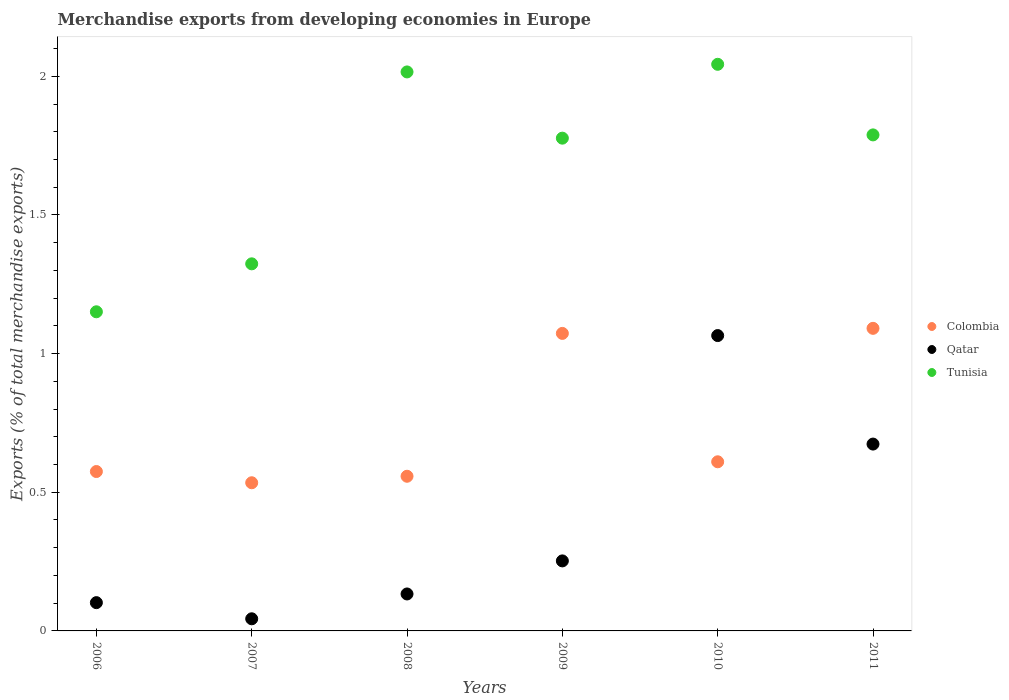What is the percentage of total merchandise exports in Colombia in 2010?
Your answer should be very brief. 0.61. Across all years, what is the maximum percentage of total merchandise exports in Colombia?
Your answer should be compact. 1.09. Across all years, what is the minimum percentage of total merchandise exports in Colombia?
Provide a succinct answer. 0.53. In which year was the percentage of total merchandise exports in Colombia maximum?
Provide a succinct answer. 2011. What is the total percentage of total merchandise exports in Qatar in the graph?
Provide a succinct answer. 2.27. What is the difference between the percentage of total merchandise exports in Qatar in 2007 and that in 2009?
Offer a very short reply. -0.21. What is the difference between the percentage of total merchandise exports in Tunisia in 2006 and the percentage of total merchandise exports in Colombia in 2007?
Provide a short and direct response. 0.62. What is the average percentage of total merchandise exports in Qatar per year?
Your answer should be very brief. 0.38. In the year 2011, what is the difference between the percentage of total merchandise exports in Qatar and percentage of total merchandise exports in Colombia?
Your answer should be very brief. -0.42. In how many years, is the percentage of total merchandise exports in Qatar greater than 1 %?
Your response must be concise. 1. What is the ratio of the percentage of total merchandise exports in Tunisia in 2008 to that in 2009?
Make the answer very short. 1.13. Is the percentage of total merchandise exports in Tunisia in 2006 less than that in 2008?
Ensure brevity in your answer.  Yes. What is the difference between the highest and the second highest percentage of total merchandise exports in Qatar?
Make the answer very short. 0.39. What is the difference between the highest and the lowest percentage of total merchandise exports in Qatar?
Provide a short and direct response. 1.02. In how many years, is the percentage of total merchandise exports in Tunisia greater than the average percentage of total merchandise exports in Tunisia taken over all years?
Keep it short and to the point. 4. Is it the case that in every year, the sum of the percentage of total merchandise exports in Qatar and percentage of total merchandise exports in Colombia  is greater than the percentage of total merchandise exports in Tunisia?
Offer a very short reply. No. Does the percentage of total merchandise exports in Qatar monotonically increase over the years?
Provide a succinct answer. No. Is the percentage of total merchandise exports in Tunisia strictly greater than the percentage of total merchandise exports in Qatar over the years?
Offer a terse response. Yes. How many dotlines are there?
Your answer should be compact. 3. What is the difference between two consecutive major ticks on the Y-axis?
Offer a terse response. 0.5. Does the graph contain any zero values?
Offer a very short reply. No. Does the graph contain grids?
Offer a terse response. No. Where does the legend appear in the graph?
Provide a short and direct response. Center right. How many legend labels are there?
Make the answer very short. 3. How are the legend labels stacked?
Your answer should be compact. Vertical. What is the title of the graph?
Offer a very short reply. Merchandise exports from developing economies in Europe. What is the label or title of the Y-axis?
Provide a succinct answer. Exports (% of total merchandise exports). What is the Exports (% of total merchandise exports) of Colombia in 2006?
Make the answer very short. 0.57. What is the Exports (% of total merchandise exports) of Qatar in 2006?
Offer a very short reply. 0.1. What is the Exports (% of total merchandise exports) of Tunisia in 2006?
Your answer should be compact. 1.15. What is the Exports (% of total merchandise exports) in Colombia in 2007?
Ensure brevity in your answer.  0.53. What is the Exports (% of total merchandise exports) of Qatar in 2007?
Offer a very short reply. 0.04. What is the Exports (% of total merchandise exports) in Tunisia in 2007?
Ensure brevity in your answer.  1.32. What is the Exports (% of total merchandise exports) of Colombia in 2008?
Your response must be concise. 0.56. What is the Exports (% of total merchandise exports) in Qatar in 2008?
Keep it short and to the point. 0.13. What is the Exports (% of total merchandise exports) of Tunisia in 2008?
Provide a short and direct response. 2.02. What is the Exports (% of total merchandise exports) of Colombia in 2009?
Keep it short and to the point. 1.07. What is the Exports (% of total merchandise exports) of Qatar in 2009?
Provide a succinct answer. 0.25. What is the Exports (% of total merchandise exports) in Tunisia in 2009?
Your response must be concise. 1.78. What is the Exports (% of total merchandise exports) in Colombia in 2010?
Make the answer very short. 0.61. What is the Exports (% of total merchandise exports) in Qatar in 2010?
Ensure brevity in your answer.  1.07. What is the Exports (% of total merchandise exports) of Tunisia in 2010?
Ensure brevity in your answer.  2.04. What is the Exports (% of total merchandise exports) of Colombia in 2011?
Provide a succinct answer. 1.09. What is the Exports (% of total merchandise exports) of Qatar in 2011?
Provide a short and direct response. 0.67. What is the Exports (% of total merchandise exports) of Tunisia in 2011?
Give a very brief answer. 1.79. Across all years, what is the maximum Exports (% of total merchandise exports) in Colombia?
Your answer should be very brief. 1.09. Across all years, what is the maximum Exports (% of total merchandise exports) of Qatar?
Give a very brief answer. 1.07. Across all years, what is the maximum Exports (% of total merchandise exports) of Tunisia?
Your answer should be compact. 2.04. Across all years, what is the minimum Exports (% of total merchandise exports) in Colombia?
Your answer should be compact. 0.53. Across all years, what is the minimum Exports (% of total merchandise exports) in Qatar?
Your response must be concise. 0.04. Across all years, what is the minimum Exports (% of total merchandise exports) in Tunisia?
Your response must be concise. 1.15. What is the total Exports (% of total merchandise exports) in Colombia in the graph?
Your response must be concise. 4.44. What is the total Exports (% of total merchandise exports) in Qatar in the graph?
Offer a very short reply. 2.27. What is the total Exports (% of total merchandise exports) in Tunisia in the graph?
Make the answer very short. 10.1. What is the difference between the Exports (% of total merchandise exports) in Colombia in 2006 and that in 2007?
Keep it short and to the point. 0.04. What is the difference between the Exports (% of total merchandise exports) of Qatar in 2006 and that in 2007?
Offer a very short reply. 0.06. What is the difference between the Exports (% of total merchandise exports) in Tunisia in 2006 and that in 2007?
Your answer should be very brief. -0.17. What is the difference between the Exports (% of total merchandise exports) in Colombia in 2006 and that in 2008?
Give a very brief answer. 0.02. What is the difference between the Exports (% of total merchandise exports) in Qatar in 2006 and that in 2008?
Provide a succinct answer. -0.03. What is the difference between the Exports (% of total merchandise exports) in Tunisia in 2006 and that in 2008?
Provide a succinct answer. -0.86. What is the difference between the Exports (% of total merchandise exports) in Colombia in 2006 and that in 2009?
Provide a succinct answer. -0.5. What is the difference between the Exports (% of total merchandise exports) of Qatar in 2006 and that in 2009?
Provide a short and direct response. -0.15. What is the difference between the Exports (% of total merchandise exports) of Tunisia in 2006 and that in 2009?
Your answer should be compact. -0.63. What is the difference between the Exports (% of total merchandise exports) in Colombia in 2006 and that in 2010?
Provide a succinct answer. -0.04. What is the difference between the Exports (% of total merchandise exports) in Qatar in 2006 and that in 2010?
Give a very brief answer. -0.96. What is the difference between the Exports (% of total merchandise exports) in Tunisia in 2006 and that in 2010?
Your response must be concise. -0.89. What is the difference between the Exports (% of total merchandise exports) in Colombia in 2006 and that in 2011?
Your answer should be compact. -0.52. What is the difference between the Exports (% of total merchandise exports) of Qatar in 2006 and that in 2011?
Keep it short and to the point. -0.57. What is the difference between the Exports (% of total merchandise exports) in Tunisia in 2006 and that in 2011?
Offer a terse response. -0.64. What is the difference between the Exports (% of total merchandise exports) in Colombia in 2007 and that in 2008?
Offer a terse response. -0.02. What is the difference between the Exports (% of total merchandise exports) of Qatar in 2007 and that in 2008?
Give a very brief answer. -0.09. What is the difference between the Exports (% of total merchandise exports) in Tunisia in 2007 and that in 2008?
Provide a short and direct response. -0.69. What is the difference between the Exports (% of total merchandise exports) in Colombia in 2007 and that in 2009?
Your response must be concise. -0.54. What is the difference between the Exports (% of total merchandise exports) of Qatar in 2007 and that in 2009?
Provide a short and direct response. -0.21. What is the difference between the Exports (% of total merchandise exports) in Tunisia in 2007 and that in 2009?
Keep it short and to the point. -0.45. What is the difference between the Exports (% of total merchandise exports) of Colombia in 2007 and that in 2010?
Make the answer very short. -0.08. What is the difference between the Exports (% of total merchandise exports) of Qatar in 2007 and that in 2010?
Make the answer very short. -1.02. What is the difference between the Exports (% of total merchandise exports) of Tunisia in 2007 and that in 2010?
Your answer should be very brief. -0.72. What is the difference between the Exports (% of total merchandise exports) in Colombia in 2007 and that in 2011?
Provide a succinct answer. -0.56. What is the difference between the Exports (% of total merchandise exports) in Qatar in 2007 and that in 2011?
Provide a succinct answer. -0.63. What is the difference between the Exports (% of total merchandise exports) in Tunisia in 2007 and that in 2011?
Your answer should be compact. -0.47. What is the difference between the Exports (% of total merchandise exports) in Colombia in 2008 and that in 2009?
Provide a succinct answer. -0.52. What is the difference between the Exports (% of total merchandise exports) of Qatar in 2008 and that in 2009?
Provide a succinct answer. -0.12. What is the difference between the Exports (% of total merchandise exports) of Tunisia in 2008 and that in 2009?
Offer a very short reply. 0.24. What is the difference between the Exports (% of total merchandise exports) of Colombia in 2008 and that in 2010?
Offer a very short reply. -0.05. What is the difference between the Exports (% of total merchandise exports) of Qatar in 2008 and that in 2010?
Offer a very short reply. -0.93. What is the difference between the Exports (% of total merchandise exports) of Tunisia in 2008 and that in 2010?
Offer a terse response. -0.03. What is the difference between the Exports (% of total merchandise exports) in Colombia in 2008 and that in 2011?
Ensure brevity in your answer.  -0.53. What is the difference between the Exports (% of total merchandise exports) in Qatar in 2008 and that in 2011?
Ensure brevity in your answer.  -0.54. What is the difference between the Exports (% of total merchandise exports) in Tunisia in 2008 and that in 2011?
Your answer should be compact. 0.23. What is the difference between the Exports (% of total merchandise exports) of Colombia in 2009 and that in 2010?
Provide a succinct answer. 0.46. What is the difference between the Exports (% of total merchandise exports) of Qatar in 2009 and that in 2010?
Offer a terse response. -0.81. What is the difference between the Exports (% of total merchandise exports) of Tunisia in 2009 and that in 2010?
Give a very brief answer. -0.27. What is the difference between the Exports (% of total merchandise exports) of Colombia in 2009 and that in 2011?
Ensure brevity in your answer.  -0.02. What is the difference between the Exports (% of total merchandise exports) in Qatar in 2009 and that in 2011?
Your answer should be very brief. -0.42. What is the difference between the Exports (% of total merchandise exports) of Tunisia in 2009 and that in 2011?
Provide a short and direct response. -0.01. What is the difference between the Exports (% of total merchandise exports) of Colombia in 2010 and that in 2011?
Your answer should be very brief. -0.48. What is the difference between the Exports (% of total merchandise exports) of Qatar in 2010 and that in 2011?
Ensure brevity in your answer.  0.39. What is the difference between the Exports (% of total merchandise exports) of Tunisia in 2010 and that in 2011?
Make the answer very short. 0.25. What is the difference between the Exports (% of total merchandise exports) in Colombia in 2006 and the Exports (% of total merchandise exports) in Qatar in 2007?
Offer a terse response. 0.53. What is the difference between the Exports (% of total merchandise exports) of Colombia in 2006 and the Exports (% of total merchandise exports) of Tunisia in 2007?
Ensure brevity in your answer.  -0.75. What is the difference between the Exports (% of total merchandise exports) in Qatar in 2006 and the Exports (% of total merchandise exports) in Tunisia in 2007?
Your answer should be very brief. -1.22. What is the difference between the Exports (% of total merchandise exports) of Colombia in 2006 and the Exports (% of total merchandise exports) of Qatar in 2008?
Ensure brevity in your answer.  0.44. What is the difference between the Exports (% of total merchandise exports) in Colombia in 2006 and the Exports (% of total merchandise exports) in Tunisia in 2008?
Make the answer very short. -1.44. What is the difference between the Exports (% of total merchandise exports) of Qatar in 2006 and the Exports (% of total merchandise exports) of Tunisia in 2008?
Offer a terse response. -1.91. What is the difference between the Exports (% of total merchandise exports) in Colombia in 2006 and the Exports (% of total merchandise exports) in Qatar in 2009?
Offer a very short reply. 0.32. What is the difference between the Exports (% of total merchandise exports) in Colombia in 2006 and the Exports (% of total merchandise exports) in Tunisia in 2009?
Give a very brief answer. -1.2. What is the difference between the Exports (% of total merchandise exports) in Qatar in 2006 and the Exports (% of total merchandise exports) in Tunisia in 2009?
Provide a short and direct response. -1.68. What is the difference between the Exports (% of total merchandise exports) of Colombia in 2006 and the Exports (% of total merchandise exports) of Qatar in 2010?
Provide a succinct answer. -0.49. What is the difference between the Exports (% of total merchandise exports) of Colombia in 2006 and the Exports (% of total merchandise exports) of Tunisia in 2010?
Offer a terse response. -1.47. What is the difference between the Exports (% of total merchandise exports) of Qatar in 2006 and the Exports (% of total merchandise exports) of Tunisia in 2010?
Your answer should be very brief. -1.94. What is the difference between the Exports (% of total merchandise exports) in Colombia in 2006 and the Exports (% of total merchandise exports) in Qatar in 2011?
Offer a very short reply. -0.1. What is the difference between the Exports (% of total merchandise exports) of Colombia in 2006 and the Exports (% of total merchandise exports) of Tunisia in 2011?
Offer a very short reply. -1.21. What is the difference between the Exports (% of total merchandise exports) in Qatar in 2006 and the Exports (% of total merchandise exports) in Tunisia in 2011?
Keep it short and to the point. -1.69. What is the difference between the Exports (% of total merchandise exports) of Colombia in 2007 and the Exports (% of total merchandise exports) of Qatar in 2008?
Give a very brief answer. 0.4. What is the difference between the Exports (% of total merchandise exports) of Colombia in 2007 and the Exports (% of total merchandise exports) of Tunisia in 2008?
Provide a succinct answer. -1.48. What is the difference between the Exports (% of total merchandise exports) of Qatar in 2007 and the Exports (% of total merchandise exports) of Tunisia in 2008?
Make the answer very short. -1.97. What is the difference between the Exports (% of total merchandise exports) in Colombia in 2007 and the Exports (% of total merchandise exports) in Qatar in 2009?
Ensure brevity in your answer.  0.28. What is the difference between the Exports (% of total merchandise exports) in Colombia in 2007 and the Exports (% of total merchandise exports) in Tunisia in 2009?
Keep it short and to the point. -1.24. What is the difference between the Exports (% of total merchandise exports) of Qatar in 2007 and the Exports (% of total merchandise exports) of Tunisia in 2009?
Make the answer very short. -1.73. What is the difference between the Exports (% of total merchandise exports) in Colombia in 2007 and the Exports (% of total merchandise exports) in Qatar in 2010?
Ensure brevity in your answer.  -0.53. What is the difference between the Exports (% of total merchandise exports) of Colombia in 2007 and the Exports (% of total merchandise exports) of Tunisia in 2010?
Your answer should be very brief. -1.51. What is the difference between the Exports (% of total merchandise exports) of Qatar in 2007 and the Exports (% of total merchandise exports) of Tunisia in 2010?
Give a very brief answer. -2. What is the difference between the Exports (% of total merchandise exports) of Colombia in 2007 and the Exports (% of total merchandise exports) of Qatar in 2011?
Give a very brief answer. -0.14. What is the difference between the Exports (% of total merchandise exports) of Colombia in 2007 and the Exports (% of total merchandise exports) of Tunisia in 2011?
Provide a succinct answer. -1.25. What is the difference between the Exports (% of total merchandise exports) in Qatar in 2007 and the Exports (% of total merchandise exports) in Tunisia in 2011?
Provide a succinct answer. -1.75. What is the difference between the Exports (% of total merchandise exports) in Colombia in 2008 and the Exports (% of total merchandise exports) in Qatar in 2009?
Keep it short and to the point. 0.31. What is the difference between the Exports (% of total merchandise exports) of Colombia in 2008 and the Exports (% of total merchandise exports) of Tunisia in 2009?
Provide a succinct answer. -1.22. What is the difference between the Exports (% of total merchandise exports) of Qatar in 2008 and the Exports (% of total merchandise exports) of Tunisia in 2009?
Provide a short and direct response. -1.64. What is the difference between the Exports (% of total merchandise exports) in Colombia in 2008 and the Exports (% of total merchandise exports) in Qatar in 2010?
Keep it short and to the point. -0.51. What is the difference between the Exports (% of total merchandise exports) in Colombia in 2008 and the Exports (% of total merchandise exports) in Tunisia in 2010?
Keep it short and to the point. -1.49. What is the difference between the Exports (% of total merchandise exports) in Qatar in 2008 and the Exports (% of total merchandise exports) in Tunisia in 2010?
Your response must be concise. -1.91. What is the difference between the Exports (% of total merchandise exports) in Colombia in 2008 and the Exports (% of total merchandise exports) in Qatar in 2011?
Ensure brevity in your answer.  -0.12. What is the difference between the Exports (% of total merchandise exports) of Colombia in 2008 and the Exports (% of total merchandise exports) of Tunisia in 2011?
Your answer should be very brief. -1.23. What is the difference between the Exports (% of total merchandise exports) of Qatar in 2008 and the Exports (% of total merchandise exports) of Tunisia in 2011?
Ensure brevity in your answer.  -1.66. What is the difference between the Exports (% of total merchandise exports) of Colombia in 2009 and the Exports (% of total merchandise exports) of Qatar in 2010?
Make the answer very short. 0.01. What is the difference between the Exports (% of total merchandise exports) of Colombia in 2009 and the Exports (% of total merchandise exports) of Tunisia in 2010?
Make the answer very short. -0.97. What is the difference between the Exports (% of total merchandise exports) of Qatar in 2009 and the Exports (% of total merchandise exports) of Tunisia in 2010?
Offer a very short reply. -1.79. What is the difference between the Exports (% of total merchandise exports) in Colombia in 2009 and the Exports (% of total merchandise exports) in Qatar in 2011?
Give a very brief answer. 0.4. What is the difference between the Exports (% of total merchandise exports) in Colombia in 2009 and the Exports (% of total merchandise exports) in Tunisia in 2011?
Offer a very short reply. -0.72. What is the difference between the Exports (% of total merchandise exports) of Qatar in 2009 and the Exports (% of total merchandise exports) of Tunisia in 2011?
Your answer should be compact. -1.54. What is the difference between the Exports (% of total merchandise exports) of Colombia in 2010 and the Exports (% of total merchandise exports) of Qatar in 2011?
Ensure brevity in your answer.  -0.06. What is the difference between the Exports (% of total merchandise exports) in Colombia in 2010 and the Exports (% of total merchandise exports) in Tunisia in 2011?
Ensure brevity in your answer.  -1.18. What is the difference between the Exports (% of total merchandise exports) in Qatar in 2010 and the Exports (% of total merchandise exports) in Tunisia in 2011?
Your answer should be very brief. -0.72. What is the average Exports (% of total merchandise exports) of Colombia per year?
Make the answer very short. 0.74. What is the average Exports (% of total merchandise exports) of Qatar per year?
Your answer should be compact. 0.38. What is the average Exports (% of total merchandise exports) of Tunisia per year?
Offer a very short reply. 1.68. In the year 2006, what is the difference between the Exports (% of total merchandise exports) of Colombia and Exports (% of total merchandise exports) of Qatar?
Your response must be concise. 0.47. In the year 2006, what is the difference between the Exports (% of total merchandise exports) of Colombia and Exports (% of total merchandise exports) of Tunisia?
Your answer should be very brief. -0.58. In the year 2006, what is the difference between the Exports (% of total merchandise exports) of Qatar and Exports (% of total merchandise exports) of Tunisia?
Ensure brevity in your answer.  -1.05. In the year 2007, what is the difference between the Exports (% of total merchandise exports) in Colombia and Exports (% of total merchandise exports) in Qatar?
Make the answer very short. 0.49. In the year 2007, what is the difference between the Exports (% of total merchandise exports) in Colombia and Exports (% of total merchandise exports) in Tunisia?
Offer a terse response. -0.79. In the year 2007, what is the difference between the Exports (% of total merchandise exports) in Qatar and Exports (% of total merchandise exports) in Tunisia?
Keep it short and to the point. -1.28. In the year 2008, what is the difference between the Exports (% of total merchandise exports) of Colombia and Exports (% of total merchandise exports) of Qatar?
Your answer should be compact. 0.42. In the year 2008, what is the difference between the Exports (% of total merchandise exports) in Colombia and Exports (% of total merchandise exports) in Tunisia?
Provide a succinct answer. -1.46. In the year 2008, what is the difference between the Exports (% of total merchandise exports) in Qatar and Exports (% of total merchandise exports) in Tunisia?
Ensure brevity in your answer.  -1.88. In the year 2009, what is the difference between the Exports (% of total merchandise exports) of Colombia and Exports (% of total merchandise exports) of Qatar?
Keep it short and to the point. 0.82. In the year 2009, what is the difference between the Exports (% of total merchandise exports) in Colombia and Exports (% of total merchandise exports) in Tunisia?
Your answer should be very brief. -0.7. In the year 2009, what is the difference between the Exports (% of total merchandise exports) in Qatar and Exports (% of total merchandise exports) in Tunisia?
Offer a very short reply. -1.52. In the year 2010, what is the difference between the Exports (% of total merchandise exports) in Colombia and Exports (% of total merchandise exports) in Qatar?
Keep it short and to the point. -0.46. In the year 2010, what is the difference between the Exports (% of total merchandise exports) in Colombia and Exports (% of total merchandise exports) in Tunisia?
Keep it short and to the point. -1.43. In the year 2010, what is the difference between the Exports (% of total merchandise exports) in Qatar and Exports (% of total merchandise exports) in Tunisia?
Your answer should be very brief. -0.98. In the year 2011, what is the difference between the Exports (% of total merchandise exports) of Colombia and Exports (% of total merchandise exports) of Qatar?
Ensure brevity in your answer.  0.42. In the year 2011, what is the difference between the Exports (% of total merchandise exports) of Colombia and Exports (% of total merchandise exports) of Tunisia?
Your answer should be very brief. -0.7. In the year 2011, what is the difference between the Exports (% of total merchandise exports) in Qatar and Exports (% of total merchandise exports) in Tunisia?
Ensure brevity in your answer.  -1.11. What is the ratio of the Exports (% of total merchandise exports) in Colombia in 2006 to that in 2007?
Offer a very short reply. 1.08. What is the ratio of the Exports (% of total merchandise exports) in Qatar in 2006 to that in 2007?
Your response must be concise. 2.33. What is the ratio of the Exports (% of total merchandise exports) in Tunisia in 2006 to that in 2007?
Offer a very short reply. 0.87. What is the ratio of the Exports (% of total merchandise exports) of Colombia in 2006 to that in 2008?
Give a very brief answer. 1.03. What is the ratio of the Exports (% of total merchandise exports) of Qatar in 2006 to that in 2008?
Make the answer very short. 0.76. What is the ratio of the Exports (% of total merchandise exports) in Tunisia in 2006 to that in 2008?
Make the answer very short. 0.57. What is the ratio of the Exports (% of total merchandise exports) of Colombia in 2006 to that in 2009?
Offer a very short reply. 0.54. What is the ratio of the Exports (% of total merchandise exports) in Qatar in 2006 to that in 2009?
Your answer should be compact. 0.4. What is the ratio of the Exports (% of total merchandise exports) in Tunisia in 2006 to that in 2009?
Your answer should be very brief. 0.65. What is the ratio of the Exports (% of total merchandise exports) of Colombia in 2006 to that in 2010?
Keep it short and to the point. 0.94. What is the ratio of the Exports (% of total merchandise exports) of Qatar in 2006 to that in 2010?
Make the answer very short. 0.1. What is the ratio of the Exports (% of total merchandise exports) of Tunisia in 2006 to that in 2010?
Make the answer very short. 0.56. What is the ratio of the Exports (% of total merchandise exports) of Colombia in 2006 to that in 2011?
Make the answer very short. 0.53. What is the ratio of the Exports (% of total merchandise exports) of Qatar in 2006 to that in 2011?
Make the answer very short. 0.15. What is the ratio of the Exports (% of total merchandise exports) in Tunisia in 2006 to that in 2011?
Offer a very short reply. 0.64. What is the ratio of the Exports (% of total merchandise exports) of Colombia in 2007 to that in 2008?
Your response must be concise. 0.96. What is the ratio of the Exports (% of total merchandise exports) in Qatar in 2007 to that in 2008?
Keep it short and to the point. 0.33. What is the ratio of the Exports (% of total merchandise exports) in Tunisia in 2007 to that in 2008?
Keep it short and to the point. 0.66. What is the ratio of the Exports (% of total merchandise exports) in Colombia in 2007 to that in 2009?
Your answer should be compact. 0.5. What is the ratio of the Exports (% of total merchandise exports) in Qatar in 2007 to that in 2009?
Offer a very short reply. 0.17. What is the ratio of the Exports (% of total merchandise exports) in Tunisia in 2007 to that in 2009?
Keep it short and to the point. 0.74. What is the ratio of the Exports (% of total merchandise exports) in Colombia in 2007 to that in 2010?
Your answer should be compact. 0.88. What is the ratio of the Exports (% of total merchandise exports) in Qatar in 2007 to that in 2010?
Provide a short and direct response. 0.04. What is the ratio of the Exports (% of total merchandise exports) in Tunisia in 2007 to that in 2010?
Give a very brief answer. 0.65. What is the ratio of the Exports (% of total merchandise exports) of Colombia in 2007 to that in 2011?
Ensure brevity in your answer.  0.49. What is the ratio of the Exports (% of total merchandise exports) in Qatar in 2007 to that in 2011?
Your answer should be very brief. 0.06. What is the ratio of the Exports (% of total merchandise exports) of Tunisia in 2007 to that in 2011?
Give a very brief answer. 0.74. What is the ratio of the Exports (% of total merchandise exports) of Colombia in 2008 to that in 2009?
Provide a succinct answer. 0.52. What is the ratio of the Exports (% of total merchandise exports) in Qatar in 2008 to that in 2009?
Provide a short and direct response. 0.53. What is the ratio of the Exports (% of total merchandise exports) in Tunisia in 2008 to that in 2009?
Make the answer very short. 1.13. What is the ratio of the Exports (% of total merchandise exports) of Colombia in 2008 to that in 2010?
Provide a short and direct response. 0.91. What is the ratio of the Exports (% of total merchandise exports) of Qatar in 2008 to that in 2010?
Provide a short and direct response. 0.13. What is the ratio of the Exports (% of total merchandise exports) of Tunisia in 2008 to that in 2010?
Make the answer very short. 0.99. What is the ratio of the Exports (% of total merchandise exports) of Colombia in 2008 to that in 2011?
Give a very brief answer. 0.51. What is the ratio of the Exports (% of total merchandise exports) in Qatar in 2008 to that in 2011?
Offer a very short reply. 0.2. What is the ratio of the Exports (% of total merchandise exports) in Tunisia in 2008 to that in 2011?
Provide a short and direct response. 1.13. What is the ratio of the Exports (% of total merchandise exports) of Colombia in 2009 to that in 2010?
Offer a terse response. 1.76. What is the ratio of the Exports (% of total merchandise exports) in Qatar in 2009 to that in 2010?
Your answer should be compact. 0.24. What is the ratio of the Exports (% of total merchandise exports) in Tunisia in 2009 to that in 2010?
Ensure brevity in your answer.  0.87. What is the ratio of the Exports (% of total merchandise exports) in Colombia in 2009 to that in 2011?
Your response must be concise. 0.98. What is the ratio of the Exports (% of total merchandise exports) of Qatar in 2009 to that in 2011?
Give a very brief answer. 0.37. What is the ratio of the Exports (% of total merchandise exports) of Colombia in 2010 to that in 2011?
Provide a succinct answer. 0.56. What is the ratio of the Exports (% of total merchandise exports) in Qatar in 2010 to that in 2011?
Your answer should be very brief. 1.58. What is the ratio of the Exports (% of total merchandise exports) of Tunisia in 2010 to that in 2011?
Provide a succinct answer. 1.14. What is the difference between the highest and the second highest Exports (% of total merchandise exports) of Colombia?
Your answer should be very brief. 0.02. What is the difference between the highest and the second highest Exports (% of total merchandise exports) of Qatar?
Offer a very short reply. 0.39. What is the difference between the highest and the second highest Exports (% of total merchandise exports) of Tunisia?
Offer a very short reply. 0.03. What is the difference between the highest and the lowest Exports (% of total merchandise exports) of Colombia?
Your answer should be compact. 0.56. What is the difference between the highest and the lowest Exports (% of total merchandise exports) of Qatar?
Your response must be concise. 1.02. What is the difference between the highest and the lowest Exports (% of total merchandise exports) of Tunisia?
Give a very brief answer. 0.89. 